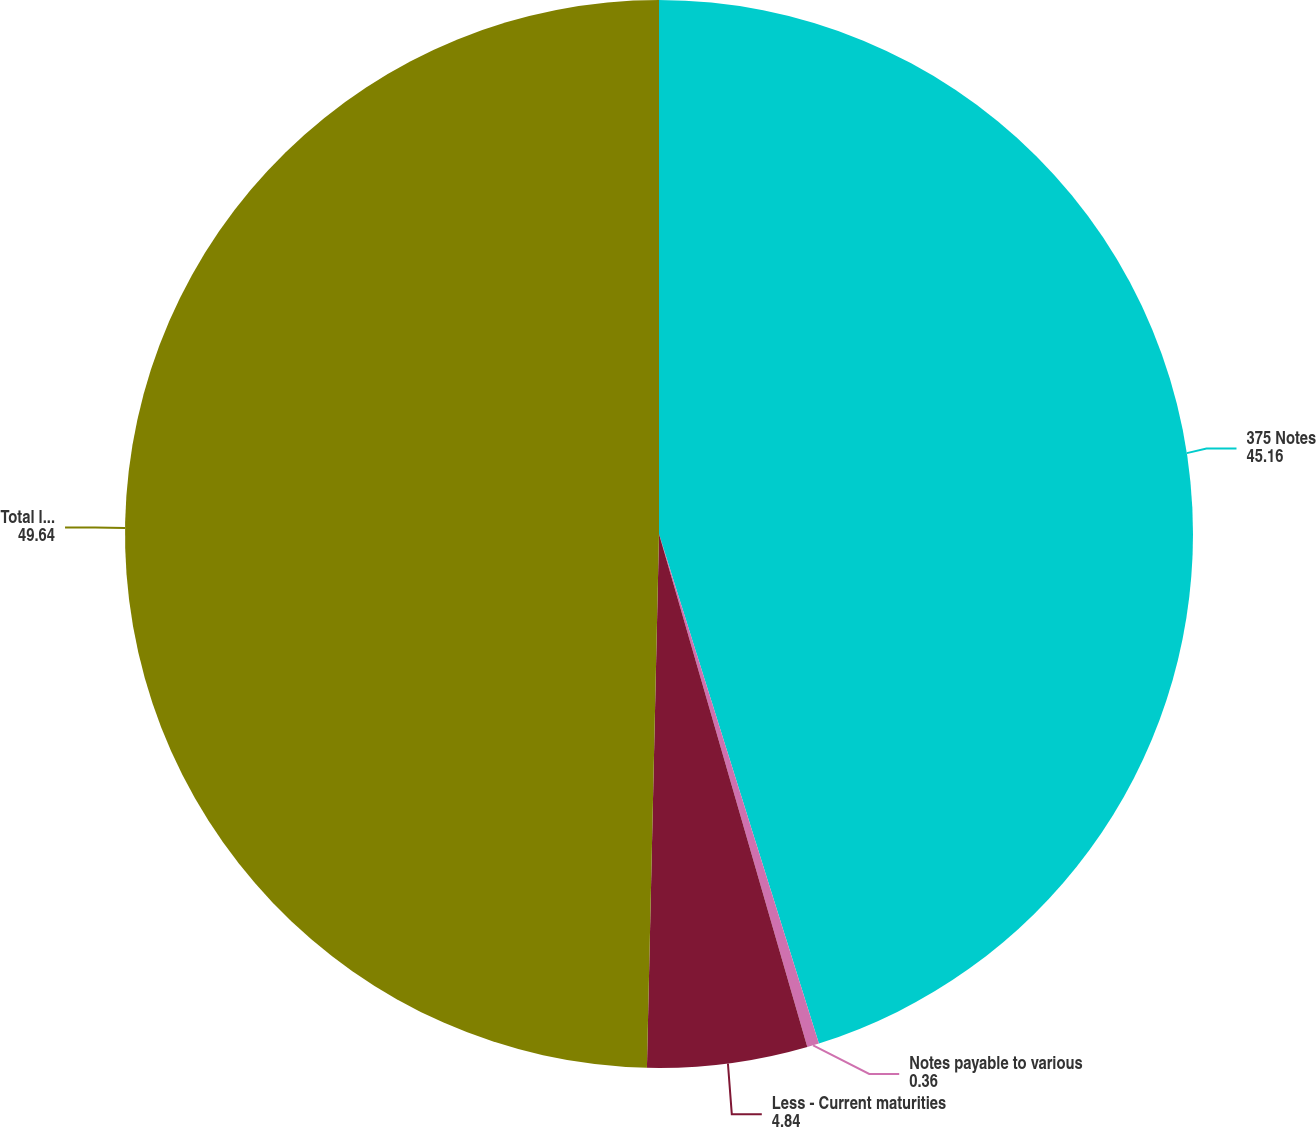Convert chart to OTSL. <chart><loc_0><loc_0><loc_500><loc_500><pie_chart><fcel>375 Notes<fcel>Notes payable to various<fcel>Less - Current maturities<fcel>Total long-term debt<nl><fcel>45.16%<fcel>0.36%<fcel>4.84%<fcel>49.64%<nl></chart> 